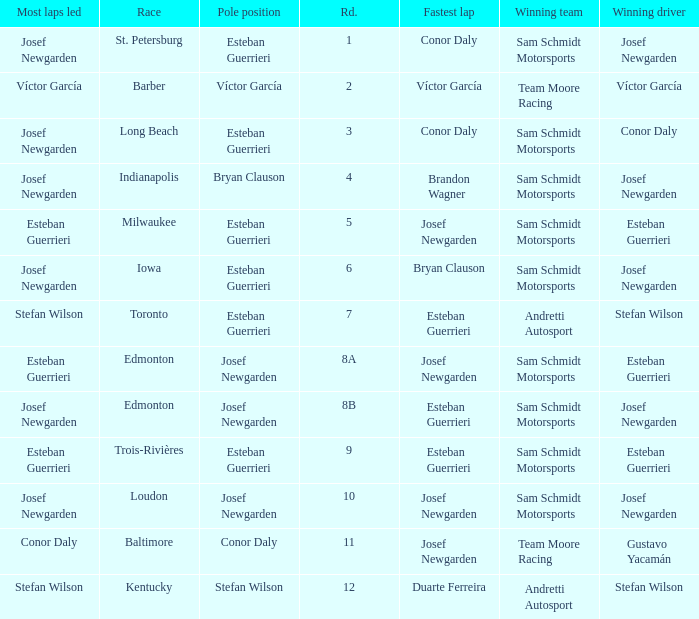Who had the fastest lap(s) when josef newgarden led the most laps at edmonton? Esteban Guerrieri. 